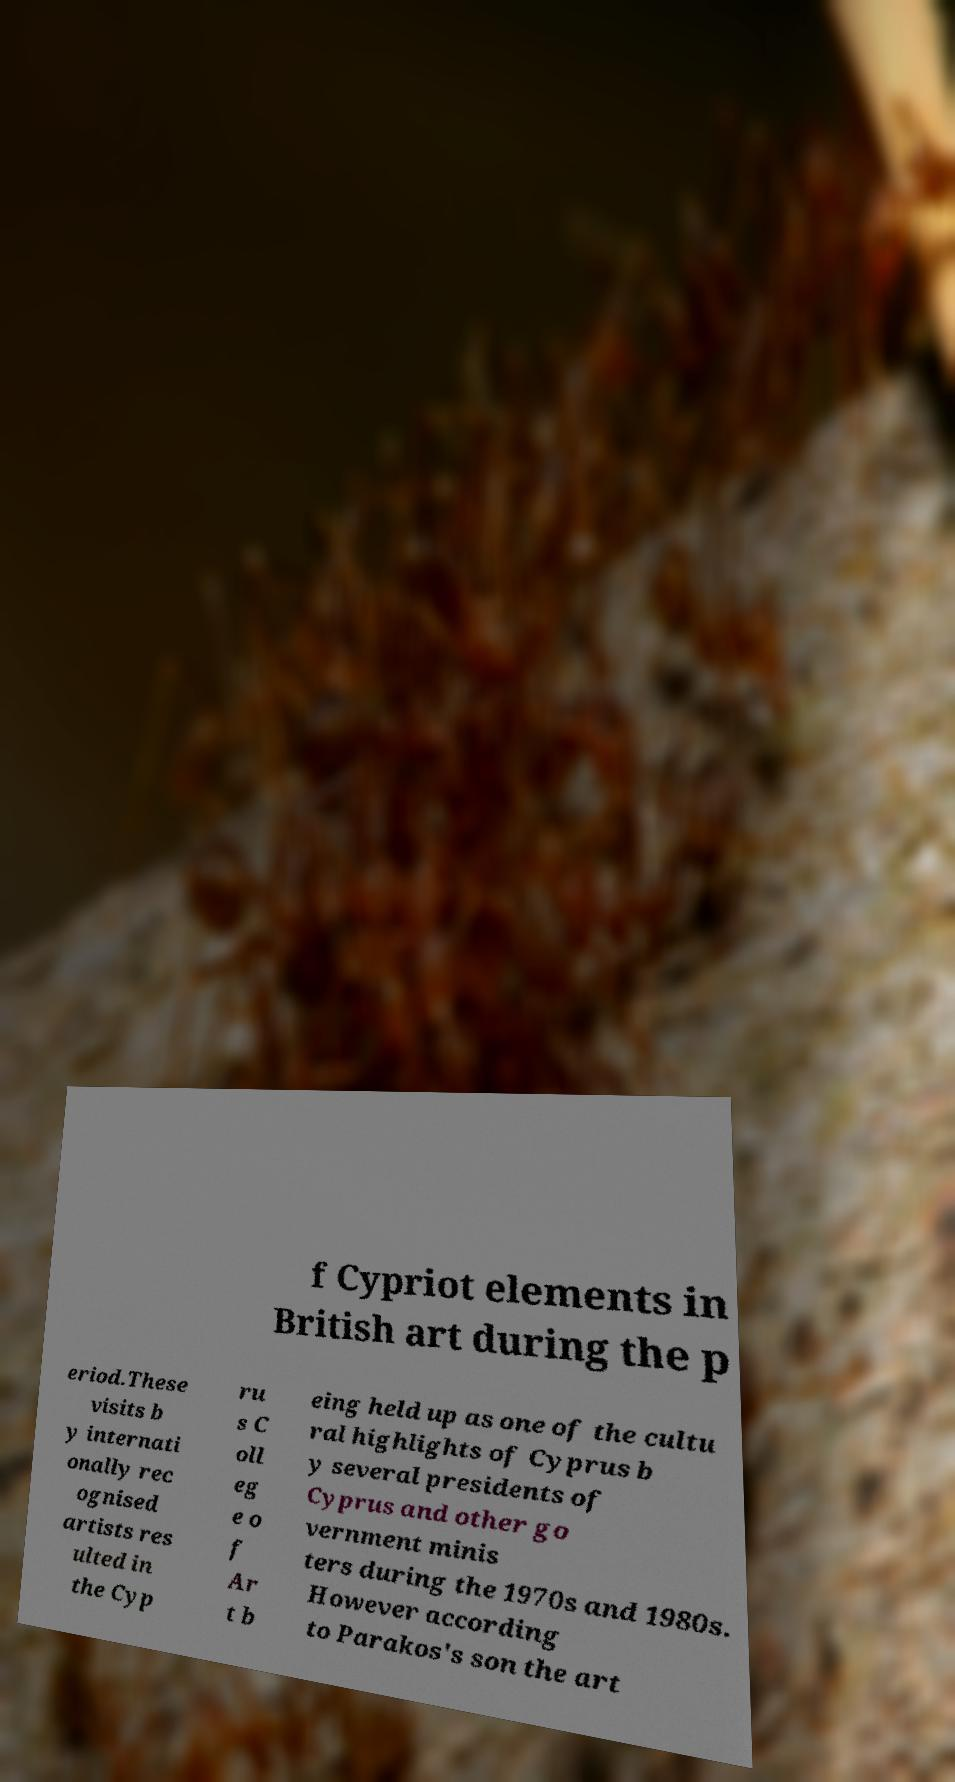I need the written content from this picture converted into text. Can you do that? f Cypriot elements in British art during the p eriod.These visits b y internati onally rec ognised artists res ulted in the Cyp ru s C oll eg e o f Ar t b eing held up as one of the cultu ral highlights of Cyprus b y several presidents of Cyprus and other go vernment minis ters during the 1970s and 1980s. However according to Parakos's son the art 